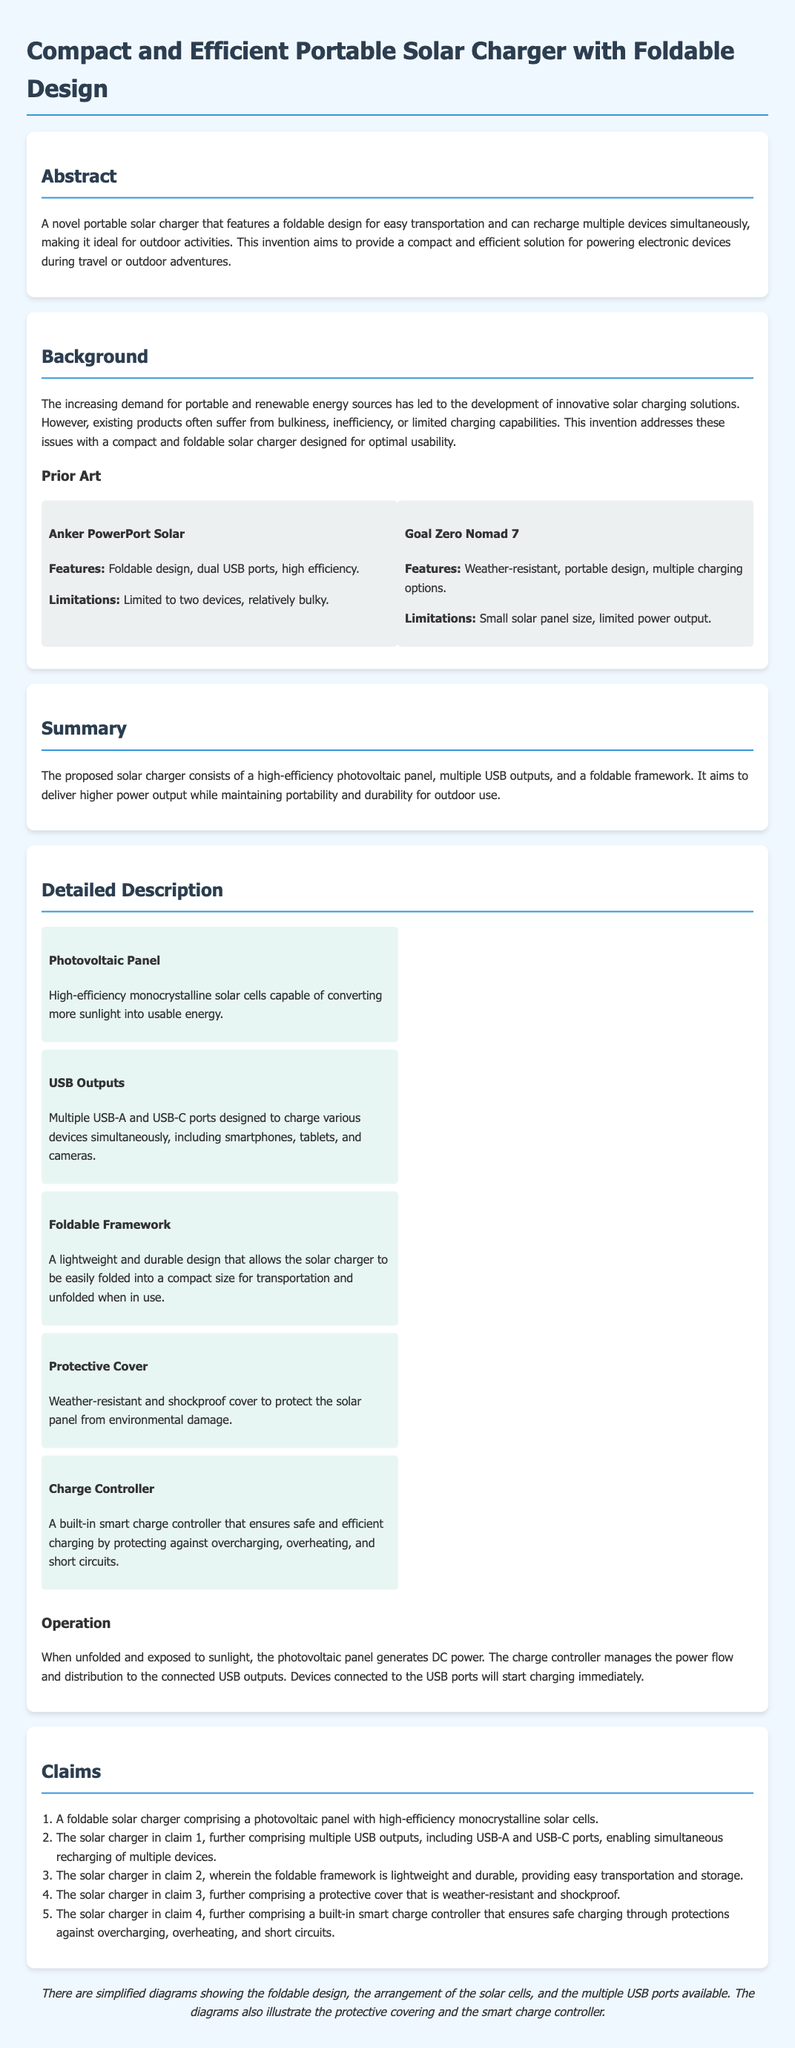What is the main purpose of the invention? The abstract states that the invention aims to provide a compact and efficient solution for powering electronic devices during travel or outdoor adventures.
Answer: Compact and efficient solution for powering electronic devices during travel or outdoor adventures How many types of USB outputs does the charger have? The detailed description specifies that the solar charger includes multiple USB-A and USB-C ports designed to charge various devices simultaneously.
Answer: Multiple (USB-A and USB-C) What are the two products mentioned in the prior art section? The prior art section lists "Anker PowerPort Solar" and "Goal Zero Nomad 7" as the two products for comparison.
Answer: Anker PowerPort Solar and Goal Zero Nomad 7 What is the protective cover described as? The detailed description indicates that the protective cover is weather-resistant and shockproof to protect the solar panel from environmental damage.
Answer: Weather-resistant and shockproof How many claims are included in the document? The claims section enumerates five claims made about the solar charger invention.
Answer: Five What is the feature that manages power flow to the connected devices? The document mentions that a built-in smart charge controller ensures safe and efficient charging and protects against overcharging, overheating, and short circuits.
Answer: Smart charge controller What type of solar cells does the photovoltaic panel use? The detailed description specifies that the photovoltaic panel will use high-efficiency monocrystalline solar cells.
Answer: High-efficiency monocrystalline solar cells In what scenario is the solar charger ideal for use? The abstract describes that the solar charger is designed for outdoor activities, making it ideal for such situations.
Answer: Outdoor activities 